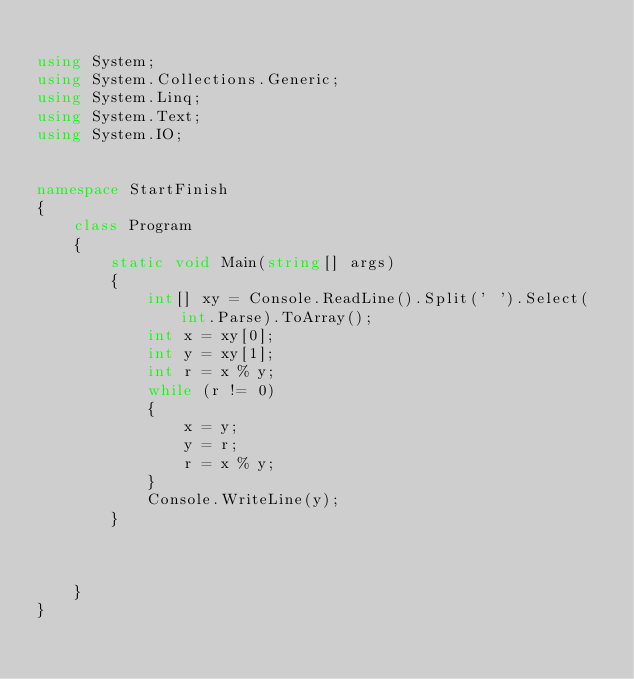Convert code to text. <code><loc_0><loc_0><loc_500><loc_500><_C#_>
using System;
using System.Collections.Generic;
using System.Linq;
using System.Text;
using System.IO;


namespace StartFinish
{
    class Program
    {   
        static void Main(string[] args)
        {
            int[] xy = Console.ReadLine().Split(' ').Select(int.Parse).ToArray();
            int x = xy[0];
            int y = xy[1];
            int r = x % y;
            while (r != 0)
            {
                x = y;
                y = r;
                r = x % y;
            }
            Console.WriteLine(y);
        }

        

    }
}</code> 